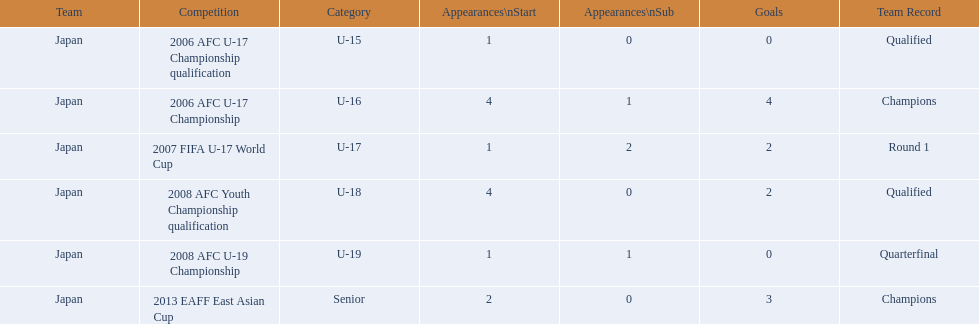Which competitions has yoichiro kakitani participated in? 2006 AFC U-17 Championship qualification, 2006 AFC U-17 Championship, 2007 FIFA U-17 World Cup, 2008 AFC Youth Championship qualification, 2008 AFC U-19 Championship, 2013 EAFF East Asian Cup. How many times did he start during each competition? 1, 4, 1, 4, 1, 2. How many goals did he score during those? 0, 4, 2, 2, 0, 3. And during which competition did yoichiro achieve the most starts and goals? 2006 AFC U-17 Championship. 